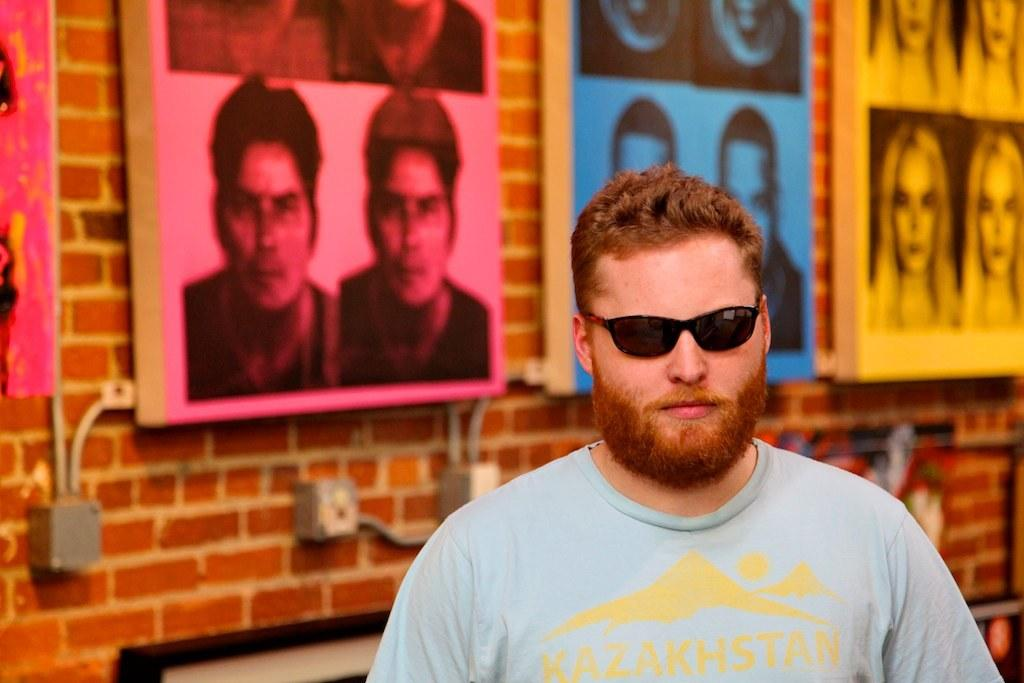Who is present in the image? There is a man in the image. What is the man wearing? The man is wearing clothes and goggles. What can be seen on the wall in the image? There are photo frames of men and women on the wall. What type of pocket can be seen in the man's clothing in the image? There is no pocket visible in the man's clothing in the image. What is the base material of the photo frames on the wall? The base material of the photo frames cannot be determined from the image. 